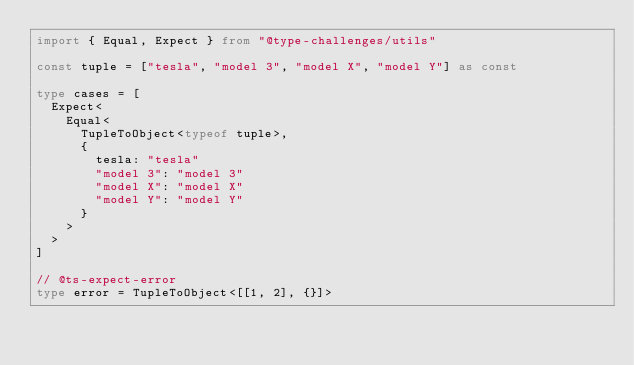Convert code to text. <code><loc_0><loc_0><loc_500><loc_500><_TypeScript_>import { Equal, Expect } from "@type-challenges/utils"

const tuple = ["tesla", "model 3", "model X", "model Y"] as const

type cases = [
  Expect<
    Equal<
      TupleToObject<typeof tuple>,
      {
        tesla: "tesla"
        "model 3": "model 3"
        "model X": "model X"
        "model Y": "model Y"
      }
    >
  >
]

// @ts-expect-error
type error = TupleToObject<[[1, 2], {}]>
</code> 